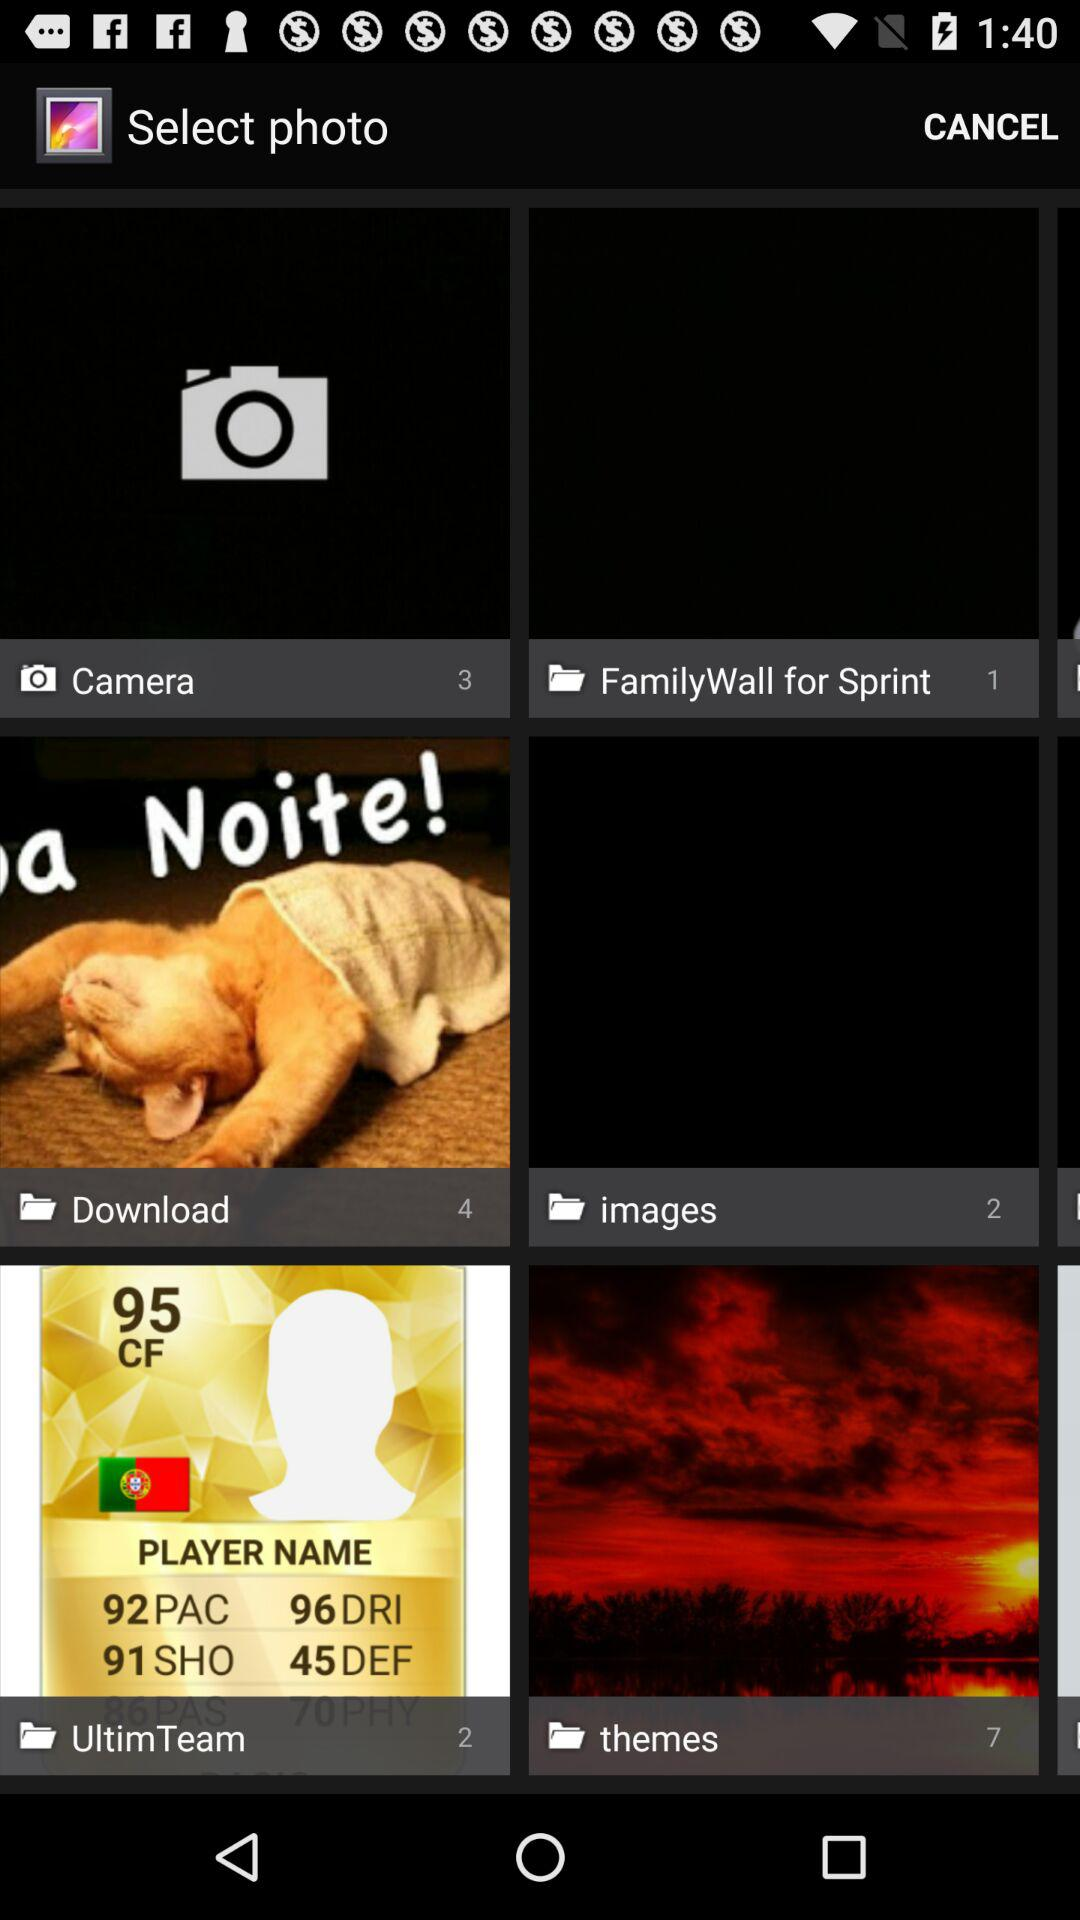What is the total number of pictures in the "UltimTeam" folder? The total number of pictures in the "UltimTeam" folder is 2. 